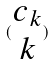<formula> <loc_0><loc_0><loc_500><loc_500>( \begin{matrix} c _ { k } \\ k \end{matrix} )</formula> 